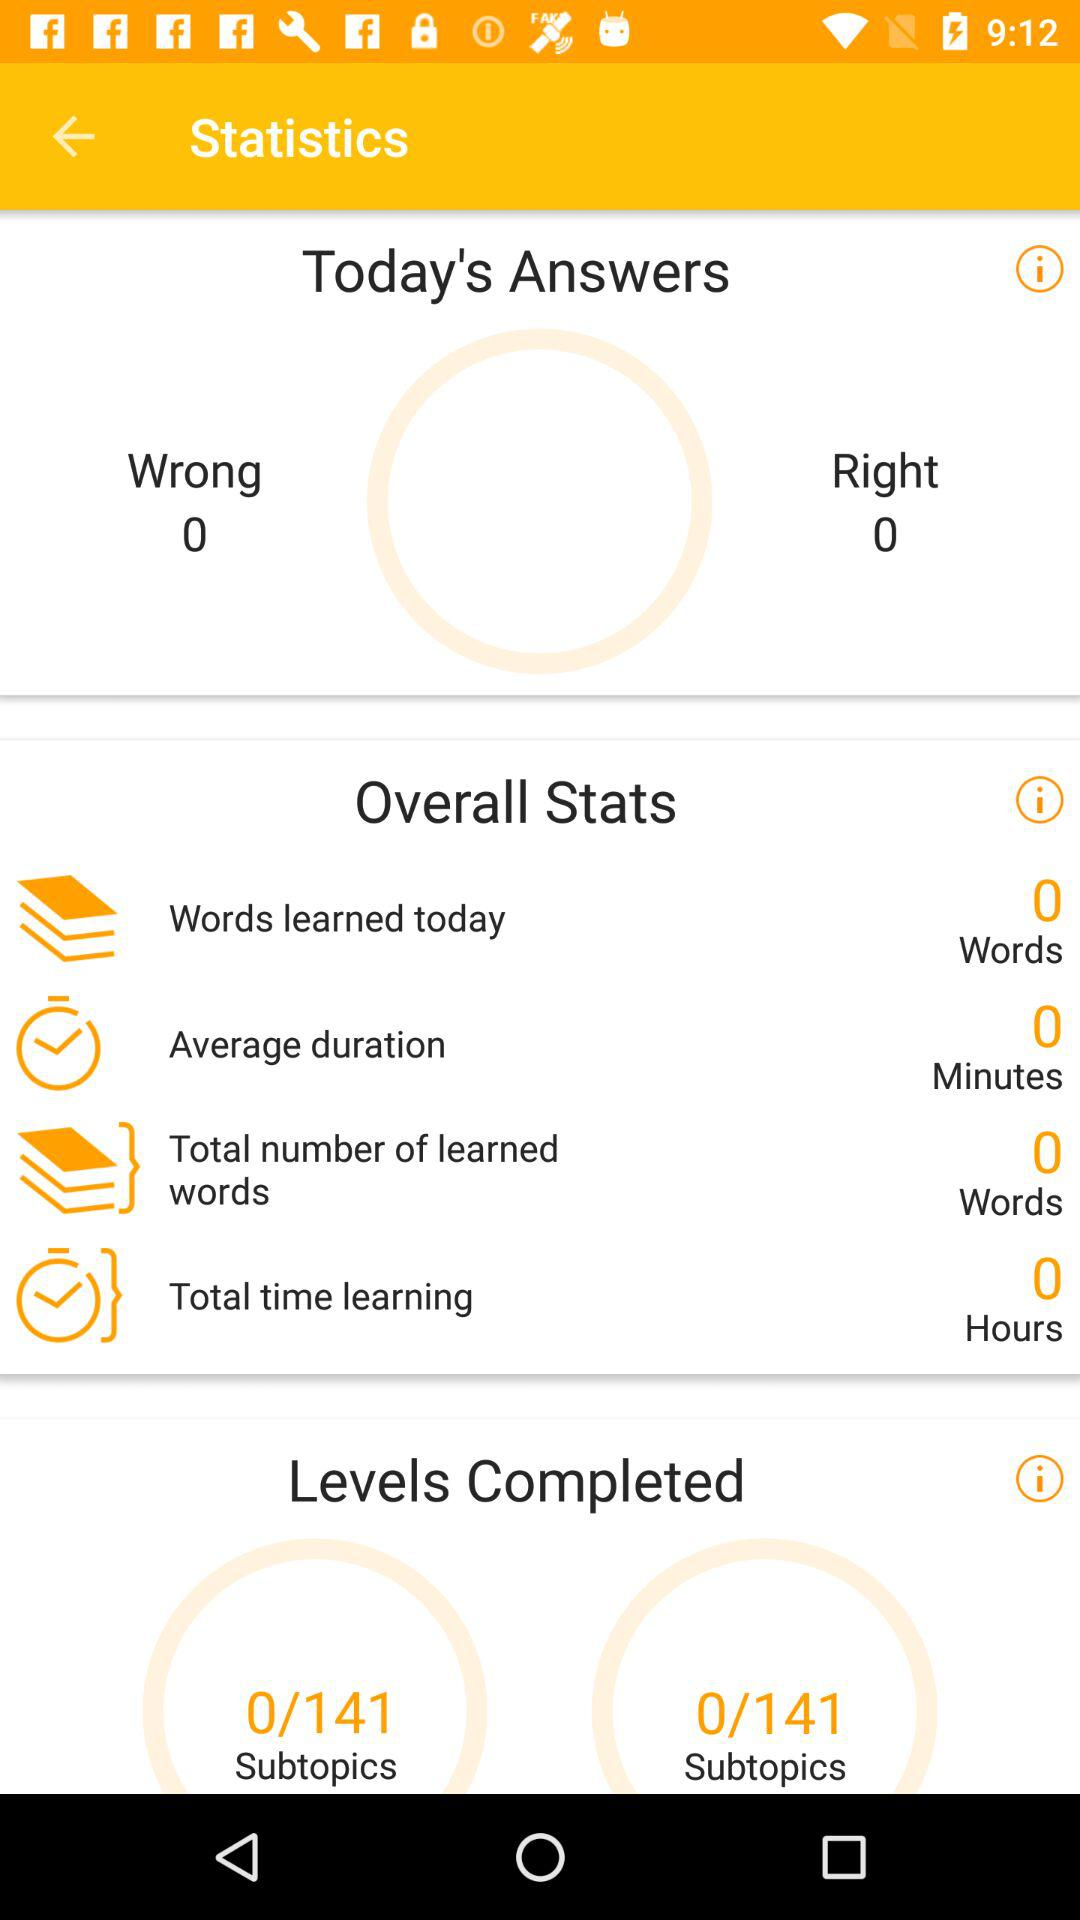What is the average duration? The average duration is 0 minutes. 